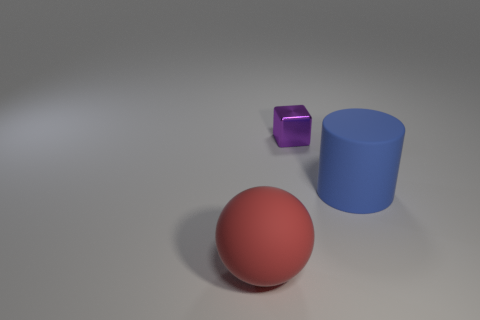Are there any other things that are made of the same material as the purple thing?
Provide a succinct answer. No. There is another object that is the same size as the red rubber object; what is it made of?
Offer a very short reply. Rubber. There is a thing in front of the matte object right of the purple metallic cube; are there any red things that are on the right side of it?
Offer a terse response. No. Is there anything else that has the same shape as the red rubber thing?
Offer a very short reply. No. There is a matte object that is on the right side of the big red matte thing; is its color the same as the matte thing in front of the blue rubber cylinder?
Offer a very short reply. No. Are there any big things?
Offer a very short reply. Yes. How big is the matte object that is in front of the large thing that is right of the big matte ball that is in front of the purple shiny object?
Offer a terse response. Large. There is a large red matte thing; is its shape the same as the object right of the purple block?
Provide a short and direct response. No. Is there another matte ball that has the same color as the big sphere?
Offer a very short reply. No. What number of blocks are large blue matte objects or red things?
Your response must be concise. 0. 